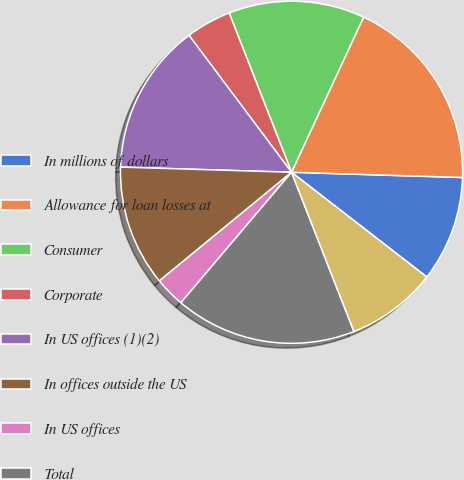<chart> <loc_0><loc_0><loc_500><loc_500><pie_chart><fcel>In millions of dollars<fcel>Allowance for loan losses at<fcel>Consumer<fcel>Corporate<fcel>In US offices (1)(2)<fcel>In offices outside the US<fcel>In US offices<fcel>Total<fcel>Other-net<nl><fcel>10.0%<fcel>18.57%<fcel>12.86%<fcel>4.29%<fcel>14.29%<fcel>11.43%<fcel>2.86%<fcel>17.14%<fcel>8.57%<nl></chart> 